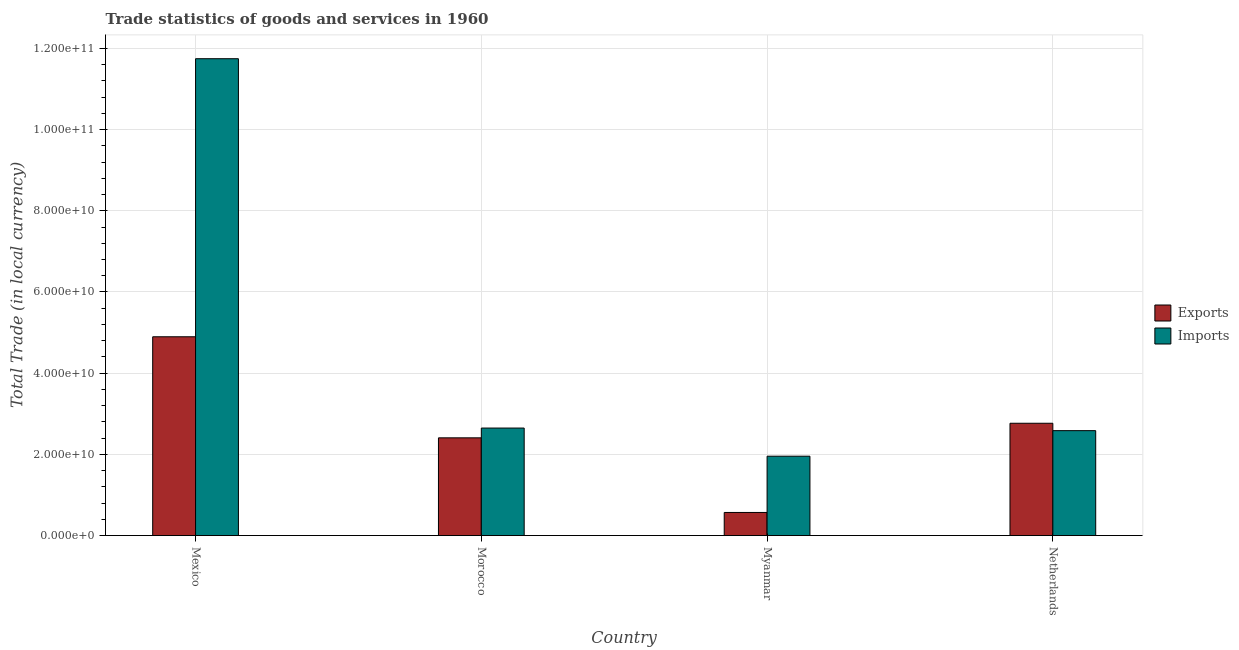How many different coloured bars are there?
Keep it short and to the point. 2. Are the number of bars per tick equal to the number of legend labels?
Your response must be concise. Yes. Are the number of bars on each tick of the X-axis equal?
Your response must be concise. Yes. What is the label of the 2nd group of bars from the left?
Ensure brevity in your answer.  Morocco. In how many cases, is the number of bars for a given country not equal to the number of legend labels?
Give a very brief answer. 0. What is the imports of goods and services in Morocco?
Your response must be concise. 2.65e+1. Across all countries, what is the maximum imports of goods and services?
Offer a terse response. 1.17e+11. Across all countries, what is the minimum export of goods and services?
Your response must be concise. 5.69e+09. In which country was the export of goods and services maximum?
Your answer should be compact. Mexico. In which country was the export of goods and services minimum?
Ensure brevity in your answer.  Myanmar. What is the total export of goods and services in the graph?
Provide a short and direct response. 1.06e+11. What is the difference between the imports of goods and services in Mexico and that in Morocco?
Make the answer very short. 9.10e+1. What is the difference between the imports of goods and services in Mexico and the export of goods and services in Myanmar?
Provide a succinct answer. 1.12e+11. What is the average export of goods and services per country?
Your answer should be very brief. 2.66e+1. What is the difference between the imports of goods and services and export of goods and services in Mexico?
Your answer should be compact. 6.85e+1. What is the ratio of the export of goods and services in Morocco to that in Netherlands?
Your answer should be compact. 0.87. What is the difference between the highest and the second highest export of goods and services?
Ensure brevity in your answer.  2.13e+1. What is the difference between the highest and the lowest imports of goods and services?
Ensure brevity in your answer.  9.79e+1. Is the sum of the imports of goods and services in Myanmar and Netherlands greater than the maximum export of goods and services across all countries?
Give a very brief answer. No. What does the 1st bar from the left in Myanmar represents?
Your answer should be compact. Exports. What does the 1st bar from the right in Morocco represents?
Ensure brevity in your answer.  Imports. What is the difference between two consecutive major ticks on the Y-axis?
Your response must be concise. 2.00e+1. How are the legend labels stacked?
Provide a succinct answer. Vertical. What is the title of the graph?
Provide a succinct answer. Trade statistics of goods and services in 1960. What is the label or title of the Y-axis?
Your response must be concise. Total Trade (in local currency). What is the Total Trade (in local currency) of Exports in Mexico?
Provide a succinct answer. 4.90e+1. What is the Total Trade (in local currency) in Imports in Mexico?
Your answer should be very brief. 1.17e+11. What is the Total Trade (in local currency) in Exports in Morocco?
Give a very brief answer. 2.41e+1. What is the Total Trade (in local currency) of Imports in Morocco?
Offer a very short reply. 2.65e+1. What is the Total Trade (in local currency) in Exports in Myanmar?
Keep it short and to the point. 5.69e+09. What is the Total Trade (in local currency) in Imports in Myanmar?
Ensure brevity in your answer.  1.96e+1. What is the Total Trade (in local currency) of Exports in Netherlands?
Make the answer very short. 2.77e+1. What is the Total Trade (in local currency) in Imports in Netherlands?
Ensure brevity in your answer.  2.58e+1. Across all countries, what is the maximum Total Trade (in local currency) of Exports?
Give a very brief answer. 4.90e+1. Across all countries, what is the maximum Total Trade (in local currency) in Imports?
Make the answer very short. 1.17e+11. Across all countries, what is the minimum Total Trade (in local currency) of Exports?
Ensure brevity in your answer.  5.69e+09. Across all countries, what is the minimum Total Trade (in local currency) of Imports?
Make the answer very short. 1.96e+1. What is the total Total Trade (in local currency) in Exports in the graph?
Ensure brevity in your answer.  1.06e+11. What is the total Total Trade (in local currency) in Imports in the graph?
Provide a short and direct response. 1.89e+11. What is the difference between the Total Trade (in local currency) of Exports in Mexico and that in Morocco?
Provide a short and direct response. 2.49e+1. What is the difference between the Total Trade (in local currency) of Imports in Mexico and that in Morocco?
Ensure brevity in your answer.  9.10e+1. What is the difference between the Total Trade (in local currency) of Exports in Mexico and that in Myanmar?
Provide a succinct answer. 4.33e+1. What is the difference between the Total Trade (in local currency) of Imports in Mexico and that in Myanmar?
Keep it short and to the point. 9.79e+1. What is the difference between the Total Trade (in local currency) in Exports in Mexico and that in Netherlands?
Ensure brevity in your answer.  2.13e+1. What is the difference between the Total Trade (in local currency) in Imports in Mexico and that in Netherlands?
Offer a very short reply. 9.16e+1. What is the difference between the Total Trade (in local currency) in Exports in Morocco and that in Myanmar?
Offer a very short reply. 1.84e+1. What is the difference between the Total Trade (in local currency) in Imports in Morocco and that in Myanmar?
Give a very brief answer. 6.93e+09. What is the difference between the Total Trade (in local currency) of Exports in Morocco and that in Netherlands?
Offer a very short reply. -3.59e+09. What is the difference between the Total Trade (in local currency) in Imports in Morocco and that in Netherlands?
Your response must be concise. 6.37e+08. What is the difference between the Total Trade (in local currency) of Exports in Myanmar and that in Netherlands?
Provide a short and direct response. -2.20e+1. What is the difference between the Total Trade (in local currency) of Imports in Myanmar and that in Netherlands?
Your response must be concise. -6.29e+09. What is the difference between the Total Trade (in local currency) in Exports in Mexico and the Total Trade (in local currency) in Imports in Morocco?
Give a very brief answer. 2.25e+1. What is the difference between the Total Trade (in local currency) of Exports in Mexico and the Total Trade (in local currency) of Imports in Myanmar?
Your answer should be compact. 2.94e+1. What is the difference between the Total Trade (in local currency) of Exports in Mexico and the Total Trade (in local currency) of Imports in Netherlands?
Give a very brief answer. 2.31e+1. What is the difference between the Total Trade (in local currency) in Exports in Morocco and the Total Trade (in local currency) in Imports in Myanmar?
Ensure brevity in your answer.  4.52e+09. What is the difference between the Total Trade (in local currency) in Exports in Morocco and the Total Trade (in local currency) in Imports in Netherlands?
Provide a short and direct response. -1.77e+09. What is the difference between the Total Trade (in local currency) of Exports in Myanmar and the Total Trade (in local currency) of Imports in Netherlands?
Your answer should be very brief. -2.02e+1. What is the average Total Trade (in local currency) of Exports per country?
Your answer should be compact. 2.66e+1. What is the average Total Trade (in local currency) in Imports per country?
Your response must be concise. 4.73e+1. What is the difference between the Total Trade (in local currency) in Exports and Total Trade (in local currency) in Imports in Mexico?
Give a very brief answer. -6.85e+1. What is the difference between the Total Trade (in local currency) of Exports and Total Trade (in local currency) of Imports in Morocco?
Offer a terse response. -2.41e+09. What is the difference between the Total Trade (in local currency) in Exports and Total Trade (in local currency) in Imports in Myanmar?
Ensure brevity in your answer.  -1.39e+1. What is the difference between the Total Trade (in local currency) in Exports and Total Trade (in local currency) in Imports in Netherlands?
Offer a terse response. 1.82e+09. What is the ratio of the Total Trade (in local currency) in Exports in Mexico to that in Morocco?
Keep it short and to the point. 2.03. What is the ratio of the Total Trade (in local currency) of Imports in Mexico to that in Morocco?
Make the answer very short. 4.44. What is the ratio of the Total Trade (in local currency) in Exports in Mexico to that in Myanmar?
Keep it short and to the point. 8.6. What is the ratio of the Total Trade (in local currency) in Imports in Mexico to that in Myanmar?
Provide a succinct answer. 6.01. What is the ratio of the Total Trade (in local currency) of Exports in Mexico to that in Netherlands?
Provide a succinct answer. 1.77. What is the ratio of the Total Trade (in local currency) in Imports in Mexico to that in Netherlands?
Ensure brevity in your answer.  4.54. What is the ratio of the Total Trade (in local currency) of Exports in Morocco to that in Myanmar?
Your answer should be very brief. 4.23. What is the ratio of the Total Trade (in local currency) of Imports in Morocco to that in Myanmar?
Offer a terse response. 1.35. What is the ratio of the Total Trade (in local currency) of Exports in Morocco to that in Netherlands?
Give a very brief answer. 0.87. What is the ratio of the Total Trade (in local currency) of Imports in Morocco to that in Netherlands?
Offer a terse response. 1.02. What is the ratio of the Total Trade (in local currency) in Exports in Myanmar to that in Netherlands?
Keep it short and to the point. 0.21. What is the ratio of the Total Trade (in local currency) of Imports in Myanmar to that in Netherlands?
Make the answer very short. 0.76. What is the difference between the highest and the second highest Total Trade (in local currency) of Exports?
Offer a very short reply. 2.13e+1. What is the difference between the highest and the second highest Total Trade (in local currency) in Imports?
Your answer should be very brief. 9.10e+1. What is the difference between the highest and the lowest Total Trade (in local currency) in Exports?
Give a very brief answer. 4.33e+1. What is the difference between the highest and the lowest Total Trade (in local currency) of Imports?
Keep it short and to the point. 9.79e+1. 